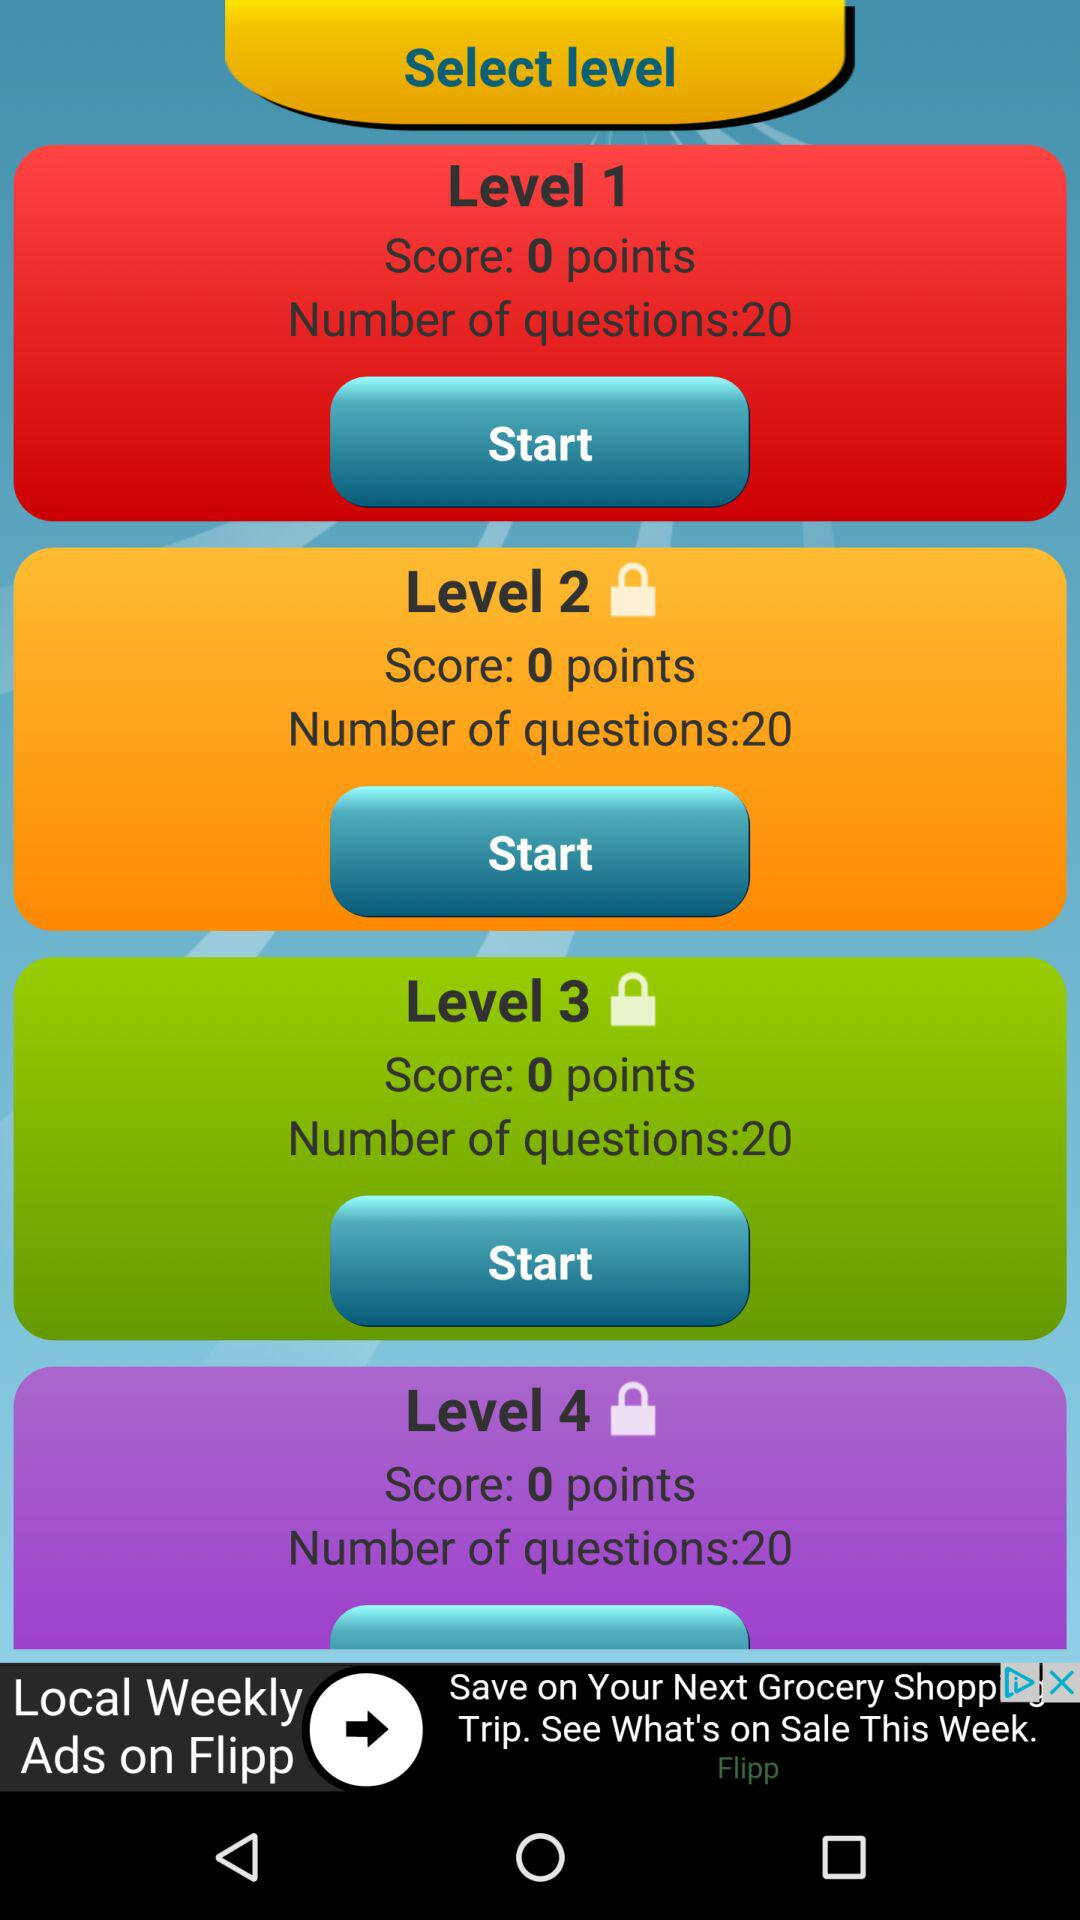How many questions are there in each level? There are 20 questions in each level. 